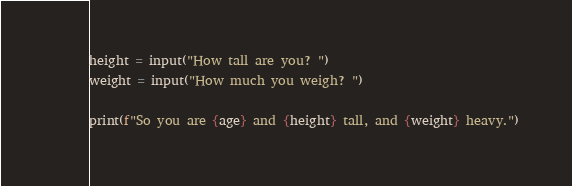<code> <loc_0><loc_0><loc_500><loc_500><_Python_>height = input("How tall are you? ")
weight = input("How much you weigh? ")

print(f"So you are {age} and {height} tall, and {weight} heavy.")</code> 